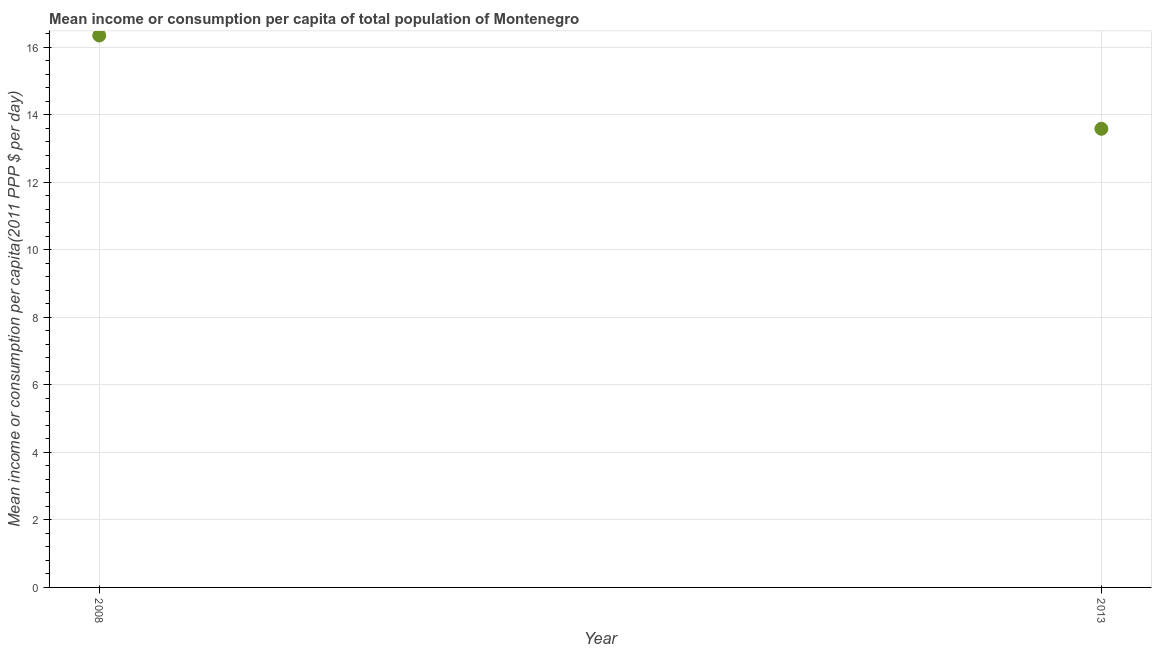What is the mean income or consumption in 2008?
Your response must be concise. 16.35. Across all years, what is the maximum mean income or consumption?
Your response must be concise. 16.35. Across all years, what is the minimum mean income or consumption?
Your response must be concise. 13.59. In which year was the mean income or consumption maximum?
Your answer should be very brief. 2008. In which year was the mean income or consumption minimum?
Ensure brevity in your answer.  2013. What is the sum of the mean income or consumption?
Make the answer very short. 29.94. What is the difference between the mean income or consumption in 2008 and 2013?
Give a very brief answer. 2.76. What is the average mean income or consumption per year?
Provide a succinct answer. 14.97. What is the median mean income or consumption?
Your answer should be very brief. 14.97. Do a majority of the years between 2013 and 2008 (inclusive) have mean income or consumption greater than 14 $?
Your answer should be very brief. No. What is the ratio of the mean income or consumption in 2008 to that in 2013?
Give a very brief answer. 1.2. How many years are there in the graph?
Provide a short and direct response. 2. What is the difference between two consecutive major ticks on the Y-axis?
Offer a terse response. 2. Does the graph contain grids?
Provide a succinct answer. Yes. What is the title of the graph?
Your response must be concise. Mean income or consumption per capita of total population of Montenegro. What is the label or title of the X-axis?
Keep it short and to the point. Year. What is the label or title of the Y-axis?
Offer a terse response. Mean income or consumption per capita(2011 PPP $ per day). What is the Mean income or consumption per capita(2011 PPP $ per day) in 2008?
Offer a terse response. 16.35. What is the Mean income or consumption per capita(2011 PPP $ per day) in 2013?
Your answer should be very brief. 13.59. What is the difference between the Mean income or consumption per capita(2011 PPP $ per day) in 2008 and 2013?
Your answer should be compact. 2.76. What is the ratio of the Mean income or consumption per capita(2011 PPP $ per day) in 2008 to that in 2013?
Make the answer very short. 1.2. 